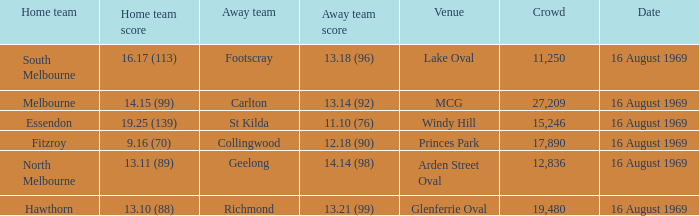What was the away team's score at Princes Park? 12.18 (90). 